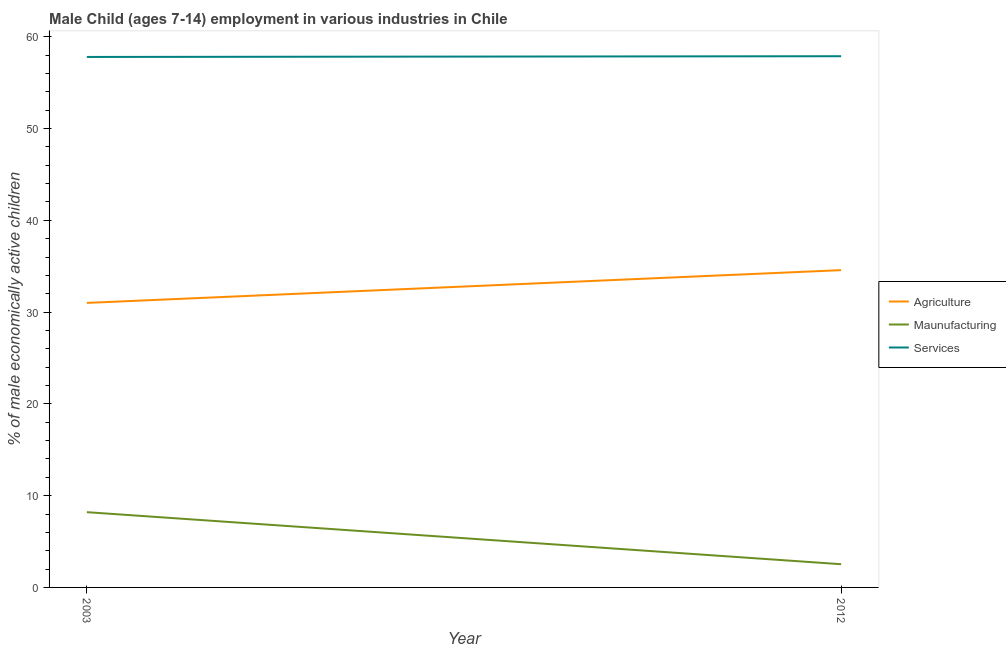Is the number of lines equal to the number of legend labels?
Give a very brief answer. Yes. What is the percentage of economically active children in agriculture in 2012?
Your answer should be compact. 34.57. Across all years, what is the maximum percentage of economically active children in agriculture?
Your answer should be very brief. 34.57. Across all years, what is the minimum percentage of economically active children in manufacturing?
Offer a terse response. 2.53. In which year was the percentage of economically active children in agriculture maximum?
Make the answer very short. 2012. What is the total percentage of economically active children in manufacturing in the graph?
Offer a very short reply. 10.73. What is the difference between the percentage of economically active children in agriculture in 2003 and that in 2012?
Ensure brevity in your answer.  -3.57. What is the difference between the percentage of economically active children in agriculture in 2012 and the percentage of economically active children in services in 2003?
Ensure brevity in your answer.  -23.23. What is the average percentage of economically active children in manufacturing per year?
Offer a terse response. 5.36. In the year 2003, what is the difference between the percentage of economically active children in agriculture and percentage of economically active children in manufacturing?
Give a very brief answer. 22.8. In how many years, is the percentage of economically active children in manufacturing greater than 58 %?
Provide a succinct answer. 0. What is the ratio of the percentage of economically active children in services in 2003 to that in 2012?
Provide a succinct answer. 1. In how many years, is the percentage of economically active children in agriculture greater than the average percentage of economically active children in agriculture taken over all years?
Ensure brevity in your answer.  1. Does the percentage of economically active children in manufacturing monotonically increase over the years?
Your answer should be compact. No. Is the percentage of economically active children in manufacturing strictly less than the percentage of economically active children in services over the years?
Make the answer very short. Yes. How many years are there in the graph?
Ensure brevity in your answer.  2. Does the graph contain grids?
Ensure brevity in your answer.  No. Where does the legend appear in the graph?
Provide a succinct answer. Center right. How many legend labels are there?
Give a very brief answer. 3. How are the legend labels stacked?
Ensure brevity in your answer.  Vertical. What is the title of the graph?
Offer a very short reply. Male Child (ages 7-14) employment in various industries in Chile. What is the label or title of the Y-axis?
Your answer should be compact. % of male economically active children. What is the % of male economically active children of Maunufacturing in 2003?
Provide a short and direct response. 8.2. What is the % of male economically active children of Services in 2003?
Provide a succinct answer. 57.8. What is the % of male economically active children of Agriculture in 2012?
Give a very brief answer. 34.57. What is the % of male economically active children in Maunufacturing in 2012?
Give a very brief answer. 2.53. What is the % of male economically active children in Services in 2012?
Provide a succinct answer. 57.88. Across all years, what is the maximum % of male economically active children of Agriculture?
Your response must be concise. 34.57. Across all years, what is the maximum % of male economically active children in Maunufacturing?
Give a very brief answer. 8.2. Across all years, what is the maximum % of male economically active children of Services?
Offer a terse response. 57.88. Across all years, what is the minimum % of male economically active children of Maunufacturing?
Your answer should be very brief. 2.53. Across all years, what is the minimum % of male economically active children of Services?
Keep it short and to the point. 57.8. What is the total % of male economically active children of Agriculture in the graph?
Your answer should be very brief. 65.57. What is the total % of male economically active children of Maunufacturing in the graph?
Offer a terse response. 10.73. What is the total % of male economically active children of Services in the graph?
Your response must be concise. 115.68. What is the difference between the % of male economically active children in Agriculture in 2003 and that in 2012?
Your answer should be compact. -3.57. What is the difference between the % of male economically active children in Maunufacturing in 2003 and that in 2012?
Give a very brief answer. 5.67. What is the difference between the % of male economically active children of Services in 2003 and that in 2012?
Your response must be concise. -0.08. What is the difference between the % of male economically active children of Agriculture in 2003 and the % of male economically active children of Maunufacturing in 2012?
Keep it short and to the point. 28.47. What is the difference between the % of male economically active children of Agriculture in 2003 and the % of male economically active children of Services in 2012?
Provide a short and direct response. -26.88. What is the difference between the % of male economically active children in Maunufacturing in 2003 and the % of male economically active children in Services in 2012?
Offer a very short reply. -49.68. What is the average % of male economically active children in Agriculture per year?
Provide a short and direct response. 32.78. What is the average % of male economically active children of Maunufacturing per year?
Provide a succinct answer. 5.37. What is the average % of male economically active children in Services per year?
Your answer should be compact. 57.84. In the year 2003, what is the difference between the % of male economically active children of Agriculture and % of male economically active children of Maunufacturing?
Give a very brief answer. 22.8. In the year 2003, what is the difference between the % of male economically active children in Agriculture and % of male economically active children in Services?
Keep it short and to the point. -26.8. In the year 2003, what is the difference between the % of male economically active children in Maunufacturing and % of male economically active children in Services?
Provide a succinct answer. -49.6. In the year 2012, what is the difference between the % of male economically active children of Agriculture and % of male economically active children of Maunufacturing?
Provide a short and direct response. 32.04. In the year 2012, what is the difference between the % of male economically active children in Agriculture and % of male economically active children in Services?
Provide a succinct answer. -23.31. In the year 2012, what is the difference between the % of male economically active children of Maunufacturing and % of male economically active children of Services?
Offer a terse response. -55.35. What is the ratio of the % of male economically active children in Agriculture in 2003 to that in 2012?
Keep it short and to the point. 0.9. What is the ratio of the % of male economically active children of Maunufacturing in 2003 to that in 2012?
Make the answer very short. 3.24. What is the difference between the highest and the second highest % of male economically active children of Agriculture?
Make the answer very short. 3.57. What is the difference between the highest and the second highest % of male economically active children of Maunufacturing?
Provide a succinct answer. 5.67. What is the difference between the highest and the second highest % of male economically active children of Services?
Offer a terse response. 0.08. What is the difference between the highest and the lowest % of male economically active children in Agriculture?
Provide a succinct answer. 3.57. What is the difference between the highest and the lowest % of male economically active children of Maunufacturing?
Give a very brief answer. 5.67. What is the difference between the highest and the lowest % of male economically active children of Services?
Provide a succinct answer. 0.08. 